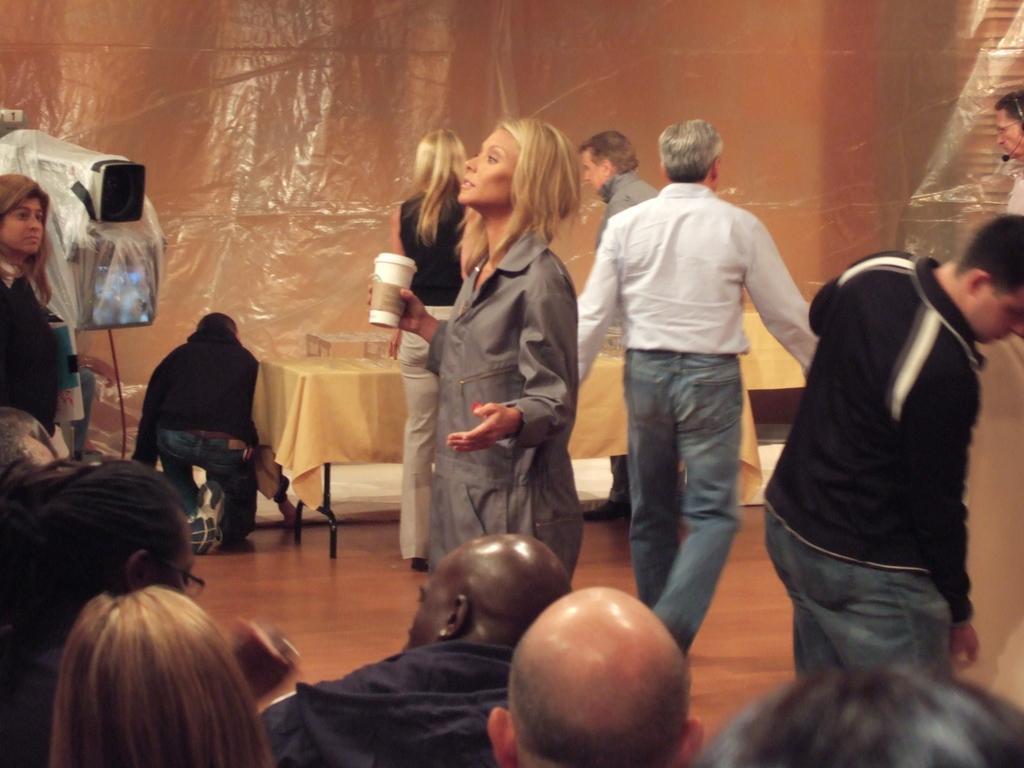Please provide a concise description of this image. In the foreground of the image there are five people sitting on the chair and in the center of the image we can see a women standing and holding a cup in her hand. On the right side of the image there is a man wearing black t shirt is standing. On the left side of the image there is a video camera. In the background of the image there is a table with the tablecloth and some things are placed on it. 